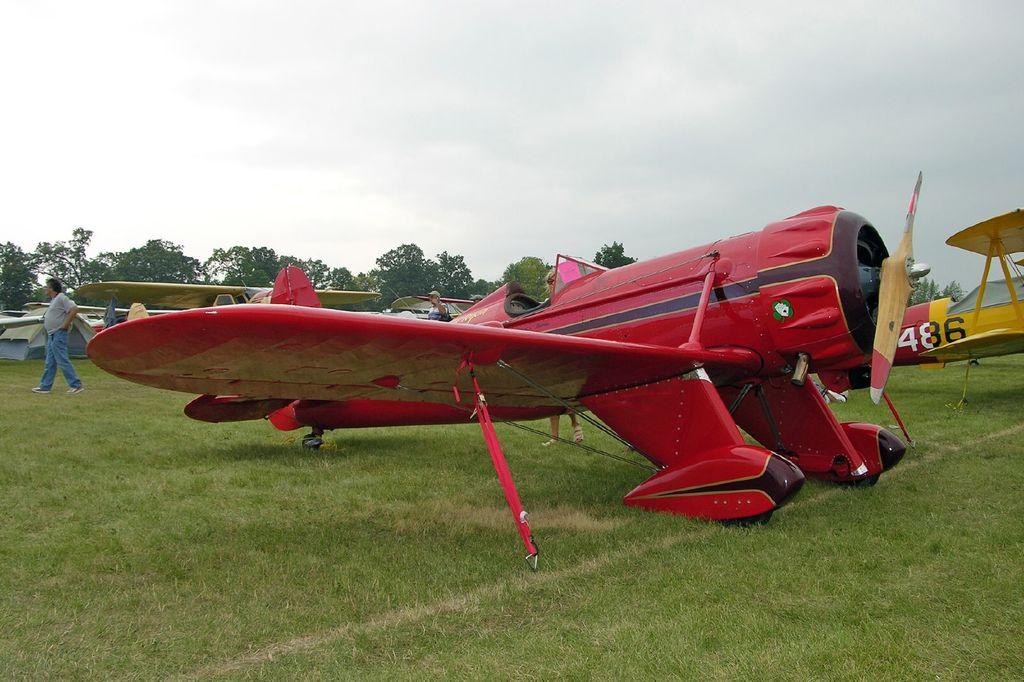What numbers are on the plane in the back?
Keep it short and to the point. 486. 